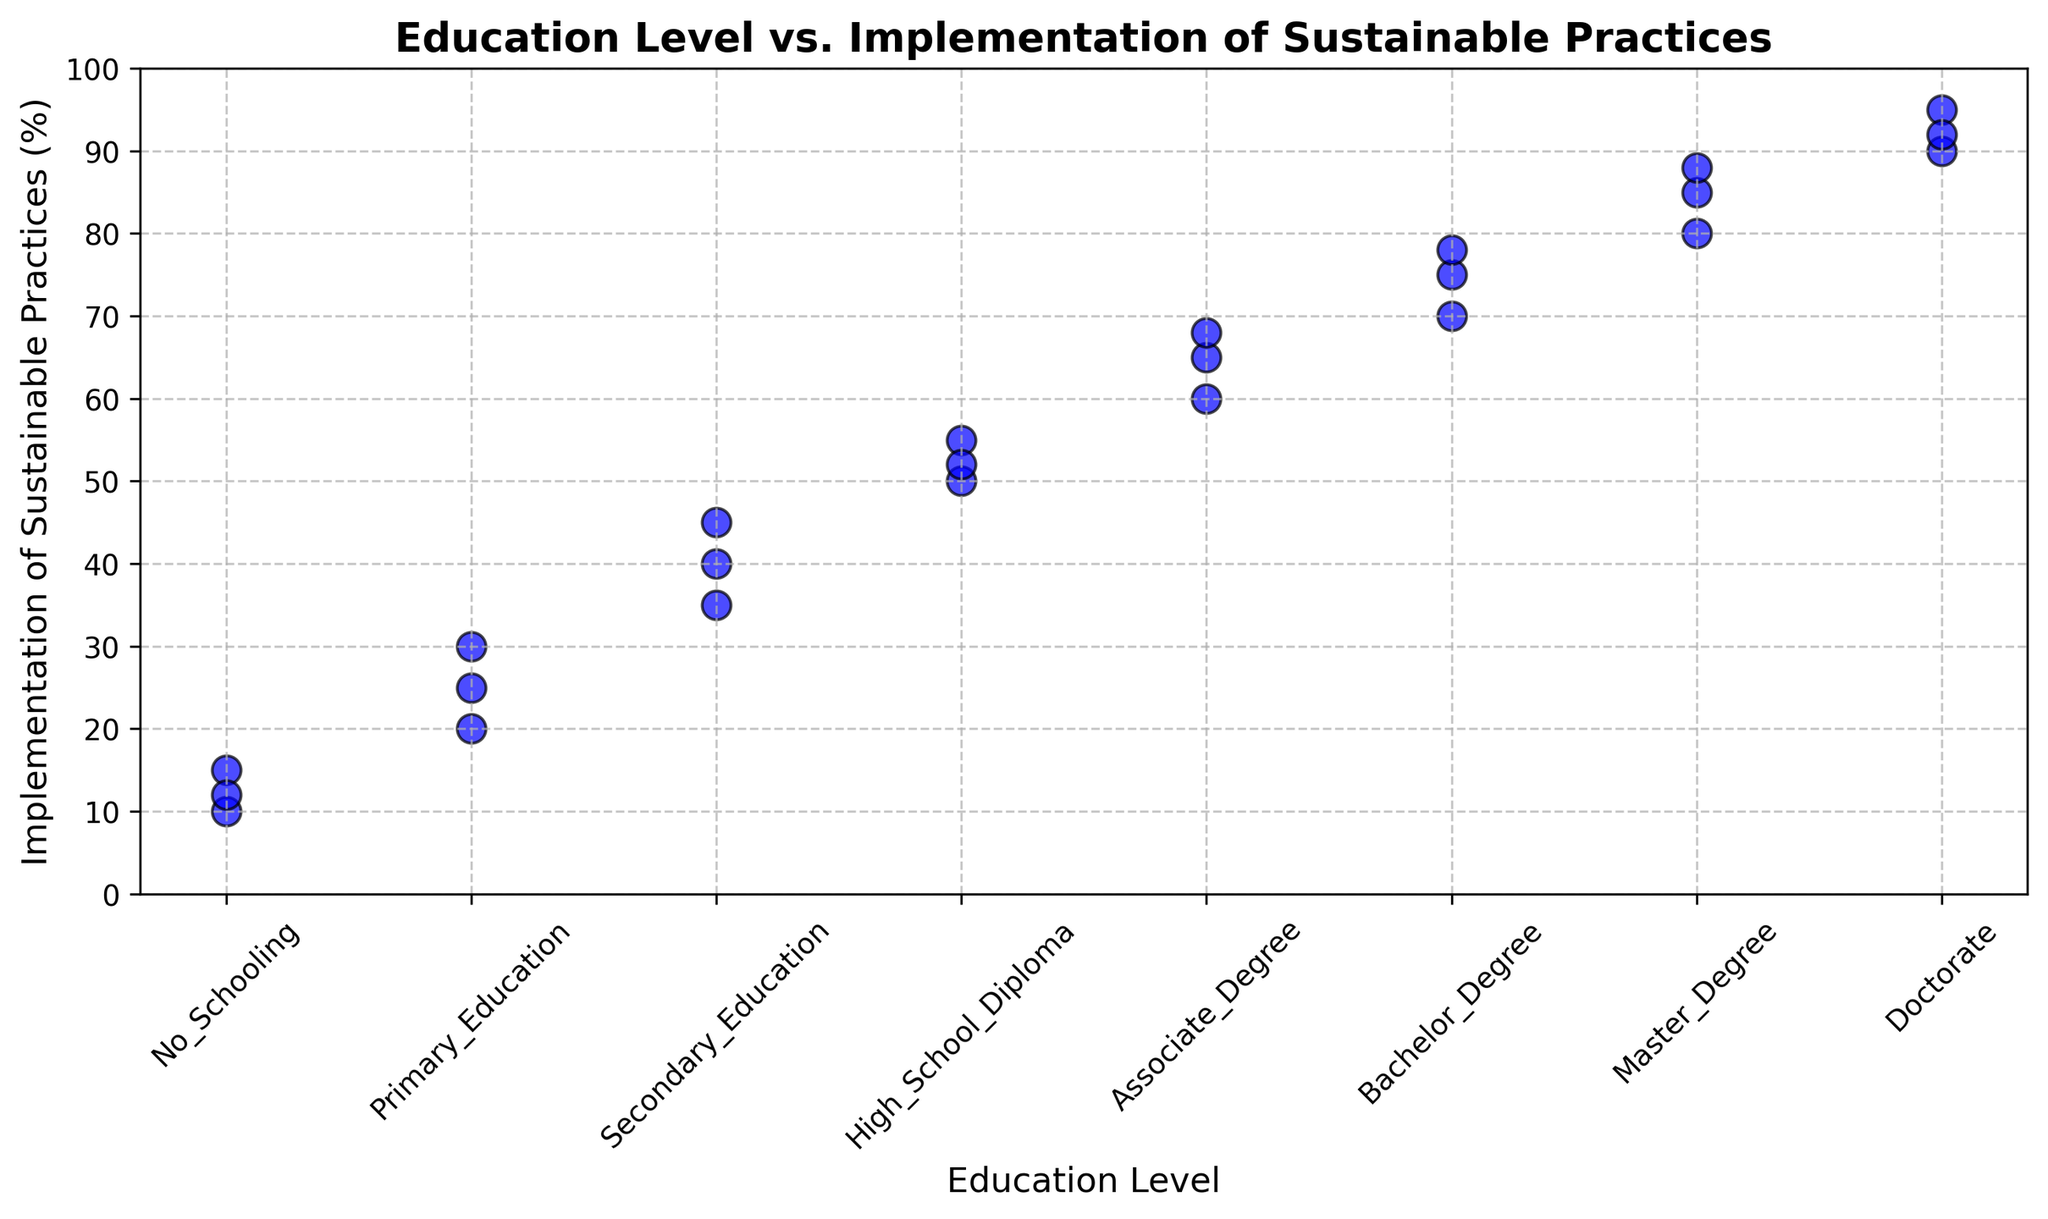What is the average implementation rate of sustainable practices for communities with a Master's Degree education level? From the graph, the implementation rates for Master's Degree holders are 80, 85, and 88. The average is calculated as (80 + 85 + 88) / 3 = 84.33.
Answer: 84.33 Which education level has the highest average implementation rate of sustainable practices? Doctorate holders have rates of 90, 95, and 92. The average is (90 + 95 + 92) / 3 = 92.33, which is higher than other education levels.
Answer: Doctorate What is the range of implementation rates for high school diploma holders? The implementation rates for high school diploma holders are 55, 50, and 52. The range is the difference between the highest and lowest values: 55 - 50 = 5.
Answer: 5 How do the average implementation rates of Bachelor's Degree compare to Associate Degree holders? The Bachelor's Degree holders have implementation rates of 75, 70, and 78 with an average of (75 + 70 + 78) / 3 = 74.33. Associate Degree holders have rates of 60, 65, and 68 with an average of (60 + 65 + 68) / 3 = 64.33. Therefore, Bachelor's Degree holders have a higher average rate.
Answer: Bachelor's Degree holders have a higher average rate Is there a noticeable trend between the education level and the implementation of sustainable practices? The scatter plot shows that as the education level increases from 'No Schooling' to 'Doctorate,' the implementation rate generally increases, suggesting a positive relationship between higher education levels and higher implementation rates of sustainable practices.
Answer: Yes, positive trend What is the median implementation rate for communities with Primary Education? The implementation rates for Primary Education are 25, 30, and 20. To find the median, we order them as 20, 25, 30. The middle value is 25.
Answer: 25 